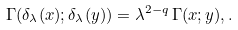<formula> <loc_0><loc_0><loc_500><loc_500>\Gamma ( \delta _ { \lambda } ( x ) ; \delta _ { \lambda } ( y ) ) = \lambda ^ { 2 - q } \, \Gamma ( x ; y ) , .</formula> 